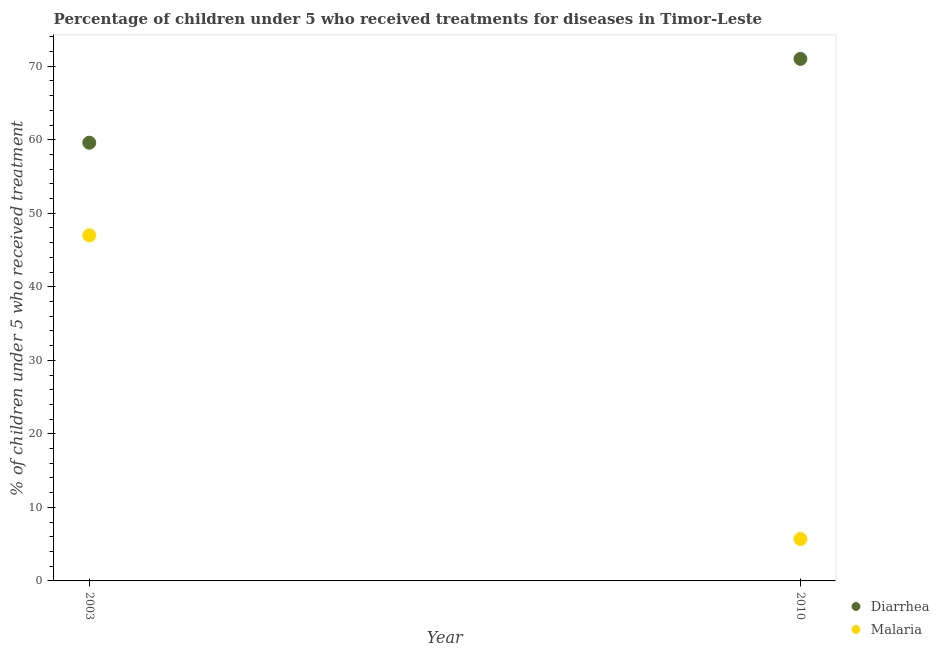Is the number of dotlines equal to the number of legend labels?
Ensure brevity in your answer.  Yes. What is the percentage of children who received treatment for diarrhoea in 2010?
Provide a short and direct response. 71. Across all years, what is the maximum percentage of children who received treatment for diarrhoea?
Keep it short and to the point. 71. What is the total percentage of children who received treatment for malaria in the graph?
Offer a terse response. 52.7. What is the difference between the percentage of children who received treatment for diarrhoea in 2003 and that in 2010?
Offer a very short reply. -11.4. What is the difference between the percentage of children who received treatment for diarrhoea in 2003 and the percentage of children who received treatment for malaria in 2010?
Give a very brief answer. 53.9. What is the average percentage of children who received treatment for malaria per year?
Your response must be concise. 26.35. In the year 2010, what is the difference between the percentage of children who received treatment for diarrhoea and percentage of children who received treatment for malaria?
Offer a terse response. 65.3. What is the ratio of the percentage of children who received treatment for malaria in 2003 to that in 2010?
Your response must be concise. 8.25. Is the percentage of children who received treatment for malaria in 2003 less than that in 2010?
Ensure brevity in your answer.  No. In how many years, is the percentage of children who received treatment for diarrhoea greater than the average percentage of children who received treatment for diarrhoea taken over all years?
Offer a very short reply. 1. Does the percentage of children who received treatment for diarrhoea monotonically increase over the years?
Your answer should be very brief. Yes. How many dotlines are there?
Provide a succinct answer. 2. How many years are there in the graph?
Your answer should be compact. 2. What is the difference between two consecutive major ticks on the Y-axis?
Give a very brief answer. 10. Are the values on the major ticks of Y-axis written in scientific E-notation?
Your answer should be very brief. No. Does the graph contain any zero values?
Your response must be concise. No. Does the graph contain grids?
Offer a very short reply. No. Where does the legend appear in the graph?
Offer a very short reply. Bottom right. What is the title of the graph?
Offer a terse response. Percentage of children under 5 who received treatments for diseases in Timor-Leste. Does "Central government" appear as one of the legend labels in the graph?
Your answer should be very brief. No. What is the label or title of the Y-axis?
Your response must be concise. % of children under 5 who received treatment. What is the % of children under 5 who received treatment of Diarrhea in 2003?
Offer a very short reply. 59.6. What is the % of children under 5 who received treatment of Malaria in 2003?
Ensure brevity in your answer.  47. What is the % of children under 5 who received treatment of Diarrhea in 2010?
Provide a short and direct response. 71. Across all years, what is the maximum % of children under 5 who received treatment of Malaria?
Your response must be concise. 47. Across all years, what is the minimum % of children under 5 who received treatment of Diarrhea?
Make the answer very short. 59.6. What is the total % of children under 5 who received treatment in Diarrhea in the graph?
Provide a succinct answer. 130.6. What is the total % of children under 5 who received treatment of Malaria in the graph?
Ensure brevity in your answer.  52.7. What is the difference between the % of children under 5 who received treatment of Diarrhea in 2003 and that in 2010?
Your response must be concise. -11.4. What is the difference between the % of children under 5 who received treatment in Malaria in 2003 and that in 2010?
Ensure brevity in your answer.  41.3. What is the difference between the % of children under 5 who received treatment in Diarrhea in 2003 and the % of children under 5 who received treatment in Malaria in 2010?
Give a very brief answer. 53.9. What is the average % of children under 5 who received treatment in Diarrhea per year?
Offer a very short reply. 65.3. What is the average % of children under 5 who received treatment of Malaria per year?
Keep it short and to the point. 26.35. In the year 2010, what is the difference between the % of children under 5 who received treatment in Diarrhea and % of children under 5 who received treatment in Malaria?
Provide a succinct answer. 65.3. What is the ratio of the % of children under 5 who received treatment in Diarrhea in 2003 to that in 2010?
Your response must be concise. 0.84. What is the ratio of the % of children under 5 who received treatment in Malaria in 2003 to that in 2010?
Your answer should be very brief. 8.25. What is the difference between the highest and the second highest % of children under 5 who received treatment in Malaria?
Provide a short and direct response. 41.3. What is the difference between the highest and the lowest % of children under 5 who received treatment in Diarrhea?
Your answer should be compact. 11.4. What is the difference between the highest and the lowest % of children under 5 who received treatment in Malaria?
Your answer should be very brief. 41.3. 